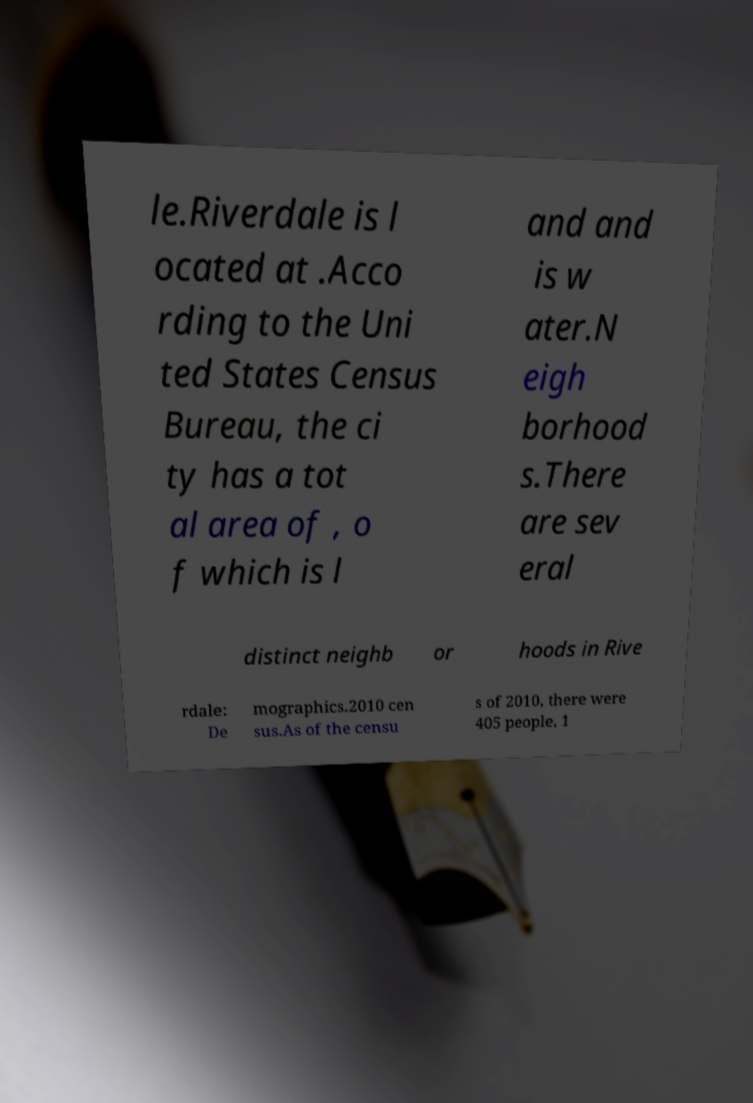I need the written content from this picture converted into text. Can you do that? le.Riverdale is l ocated at .Acco rding to the Uni ted States Census Bureau, the ci ty has a tot al area of , o f which is l and and is w ater.N eigh borhood s.There are sev eral distinct neighb or hoods in Rive rdale: De mographics.2010 cen sus.As of the censu s of 2010, there were 405 people, 1 